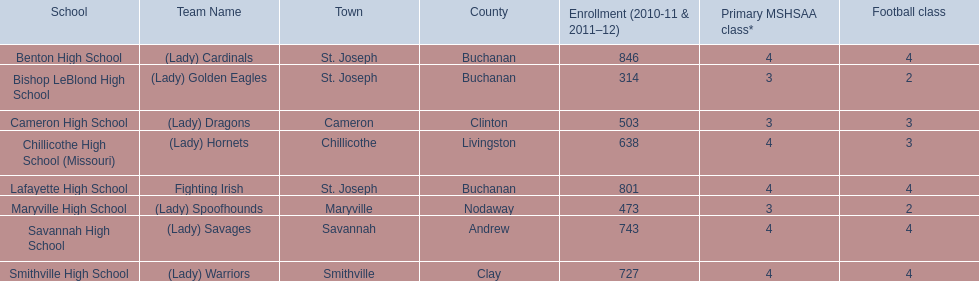Benton high school and bishop leblond high school can both be found in which town? St. Joseph. Could you help me parse every detail presented in this table? {'header': ['School', 'Team Name', 'Town', 'County', 'Enrollment (2010-11 & 2011–12)', 'Primary MSHSAA class*', 'Football class'], 'rows': [['Benton High School', '(Lady) Cardinals', 'St. Joseph', 'Buchanan', '846', '4', '4'], ['Bishop LeBlond High School', '(Lady) Golden Eagles', 'St. Joseph', 'Buchanan', '314', '3', '2'], ['Cameron High School', '(Lady) Dragons', 'Cameron', 'Clinton', '503', '3', '3'], ['Chillicothe High School (Missouri)', '(Lady) Hornets', 'Chillicothe', 'Livingston', '638', '4', '3'], ['Lafayette High School', 'Fighting Irish', 'St. Joseph', 'Buchanan', '801', '4', '4'], ['Maryville High School', '(Lady) Spoofhounds', 'Maryville', 'Nodaway', '473', '3', '2'], ['Savannah High School', '(Lady) Savages', 'Savannah', 'Andrew', '743', '4', '4'], ['Smithville High School', '(Lady) Warriors', 'Smithville', 'Clay', '727', '4', '4']]} 